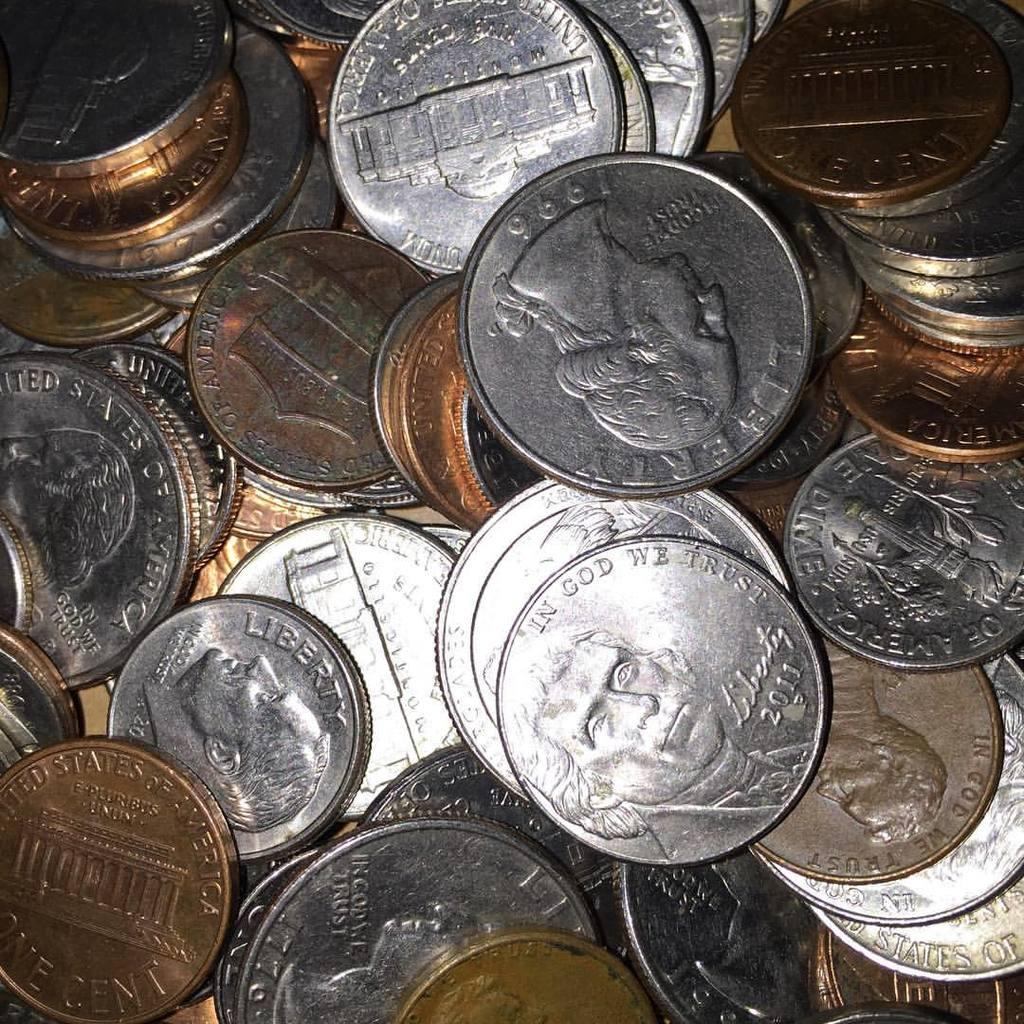Provide a one-sentence caption for the provided image. a pile of american coins with a nickle reading in god we trust on top. 